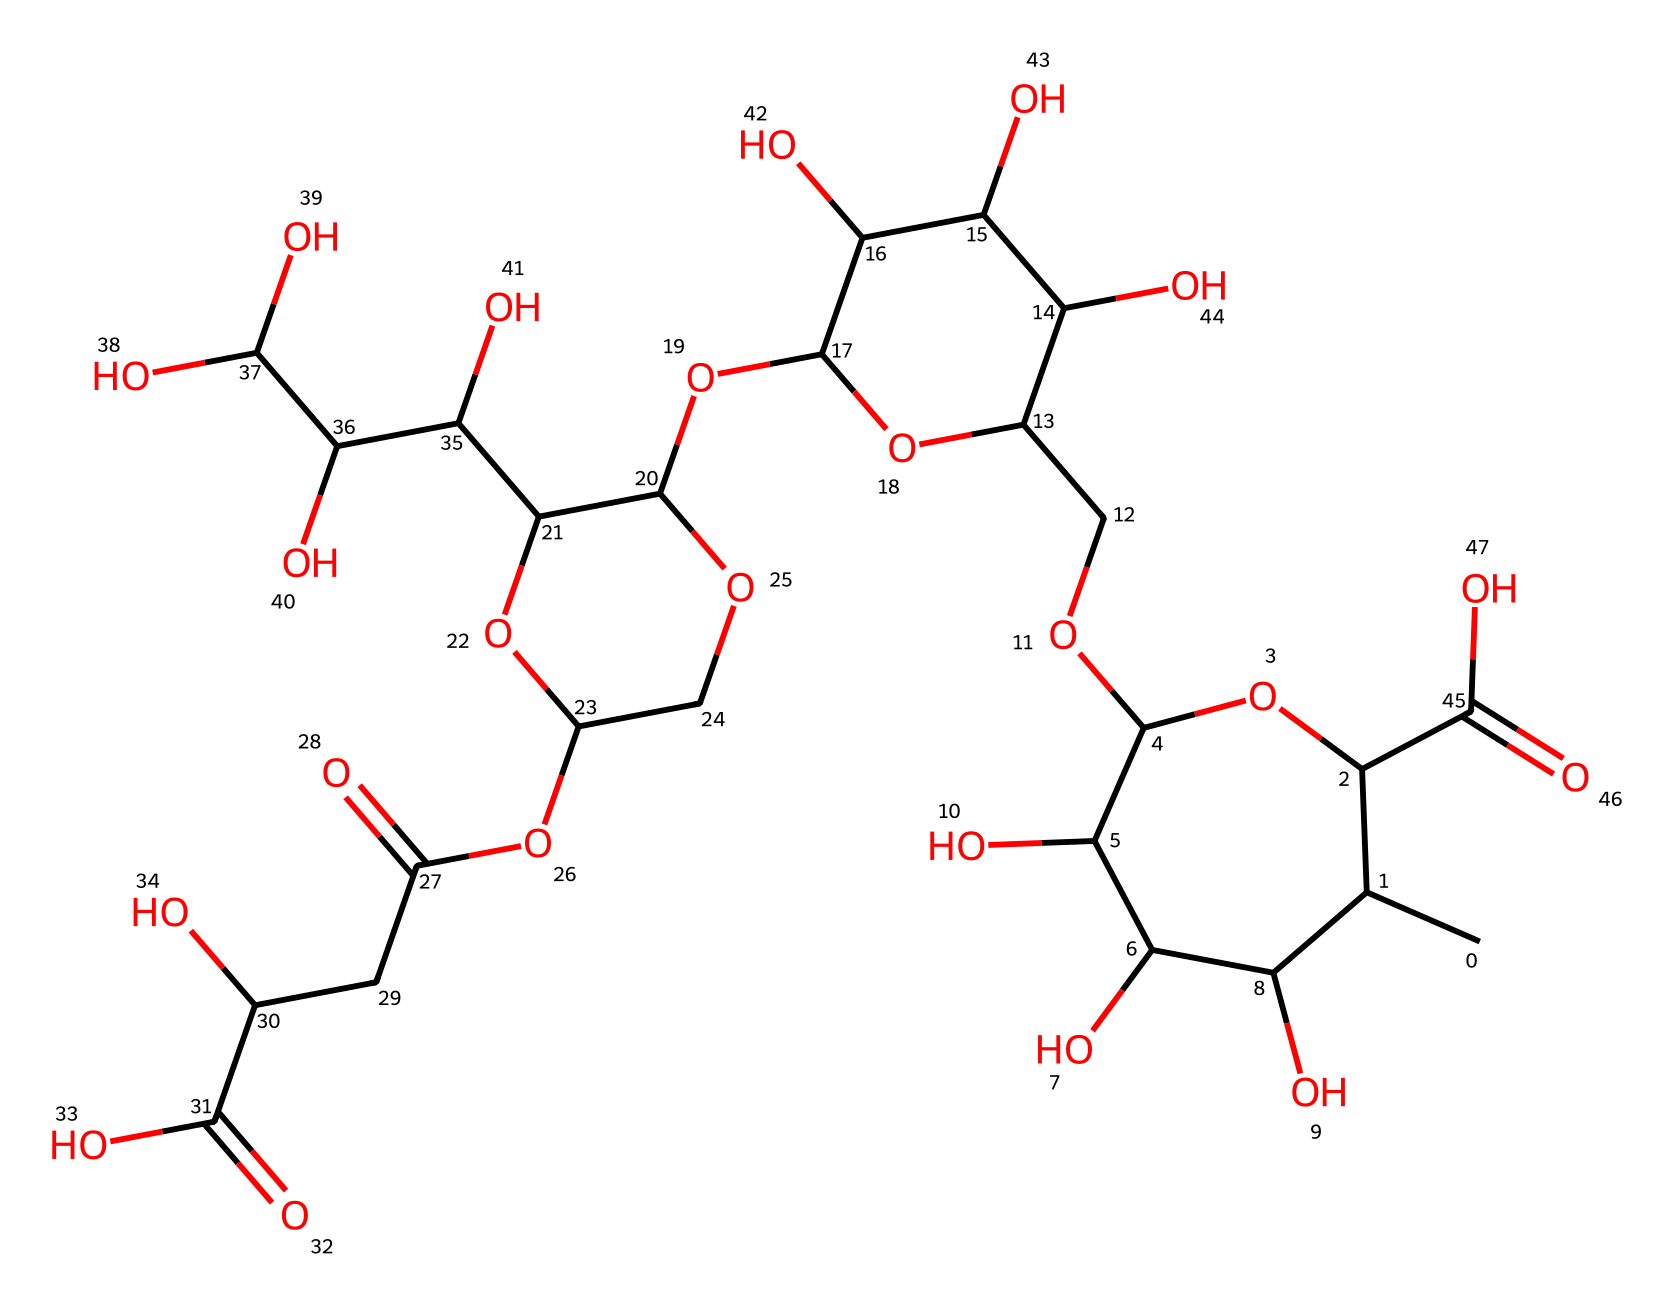What is the main functional group present in xanthan gum? The presence of the hydroxyl groups (-OH) in the structure indicates that xanthan gum has multiple alcohol functional groups.
Answer: hydroxyl groups How many ring structures are in xanthan gum? By examining the structure closely, there are three distinct ring systems noted in the chemical.
Answer: three What type of bond is most abundant in xanthan gum? The structure consists mainly of single bonds (sigma bonds) characterized by connecting carbon atoms and functional groups, especially around the sugars.
Answer: single bonds Which segment of the structure contributes to its viscosity? The presence of branched polysaccharide components, particularly the hydration of the hydroxyl groups, adds to the thickening and viscosity properties of xanthan gum.
Answer: branched polysaccharide How many carboxylic acid groups are present? On the structure, there are two noticeable carboxylic acid groups indicated by the -COOH functional group present in the structure.
Answer: two What specific property of xanthan gum makes it a non-Newtonian fluid? The shear-thinning behavior, where the viscosity decreases under stress, is due to the molecular arrangement and interactions of the polymer chains in xanthan gum.
Answer: shear-thinning behavior 